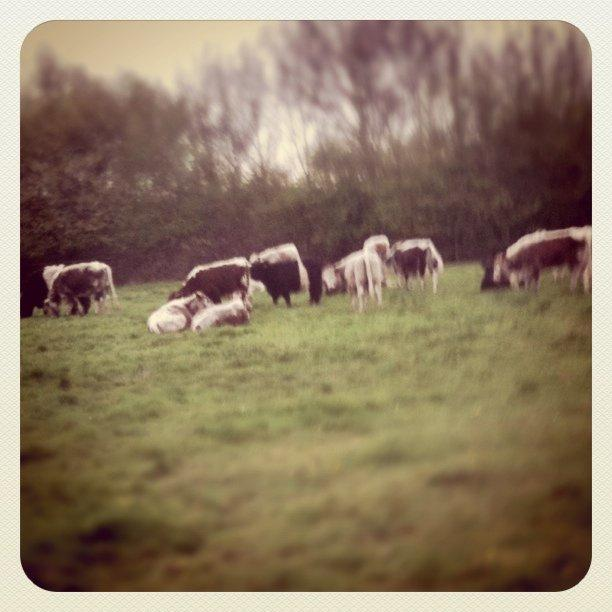What is wrong with this image? blurry 